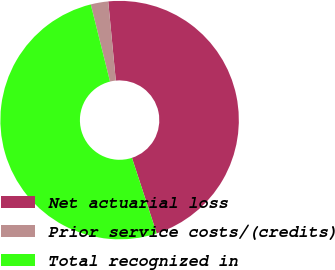<chart> <loc_0><loc_0><loc_500><loc_500><pie_chart><fcel>Net actuarial loss<fcel>Prior service costs/(credits)<fcel>Total recognized in<nl><fcel>46.49%<fcel>2.37%<fcel>51.14%<nl></chart> 